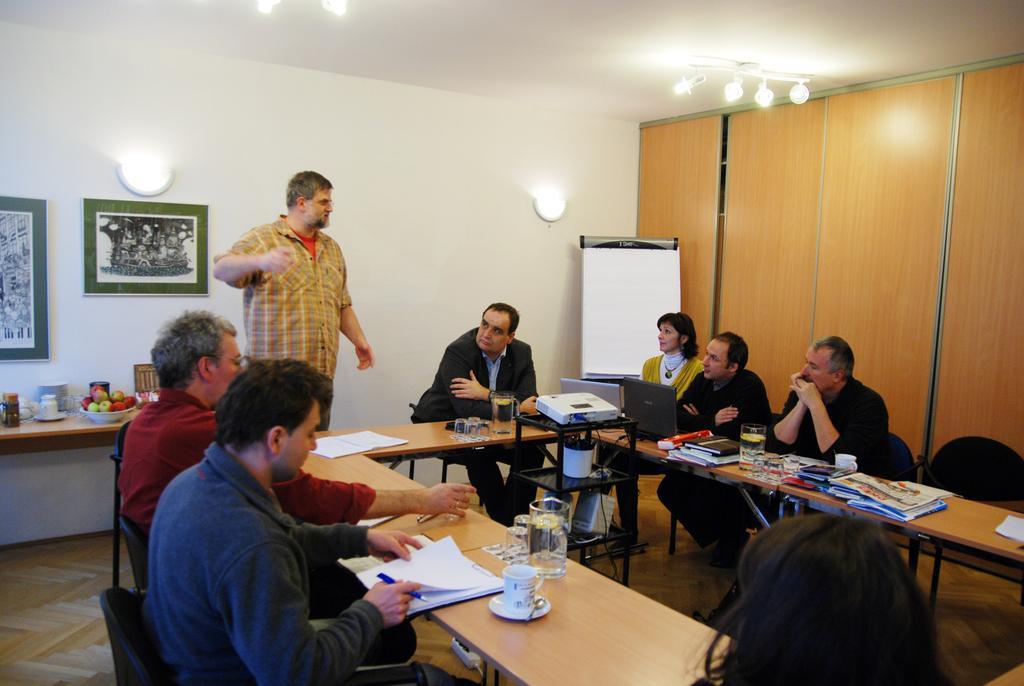Can you describe this image briefly? In this image we can see this people are sitting on the chairs near table. There are books, papers, cups, glasses, projector and laptop on the table. In the background we can see a man standing, photo frame on wall, fruit bowl on table and cupboards. 